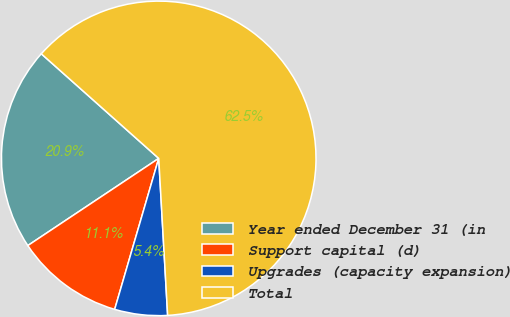Convert chart. <chart><loc_0><loc_0><loc_500><loc_500><pie_chart><fcel>Year ended December 31 (in<fcel>Support capital (d)<fcel>Upgrades (capacity expansion)<fcel>Total<nl><fcel>20.93%<fcel>11.13%<fcel>5.42%<fcel>62.51%<nl></chart> 